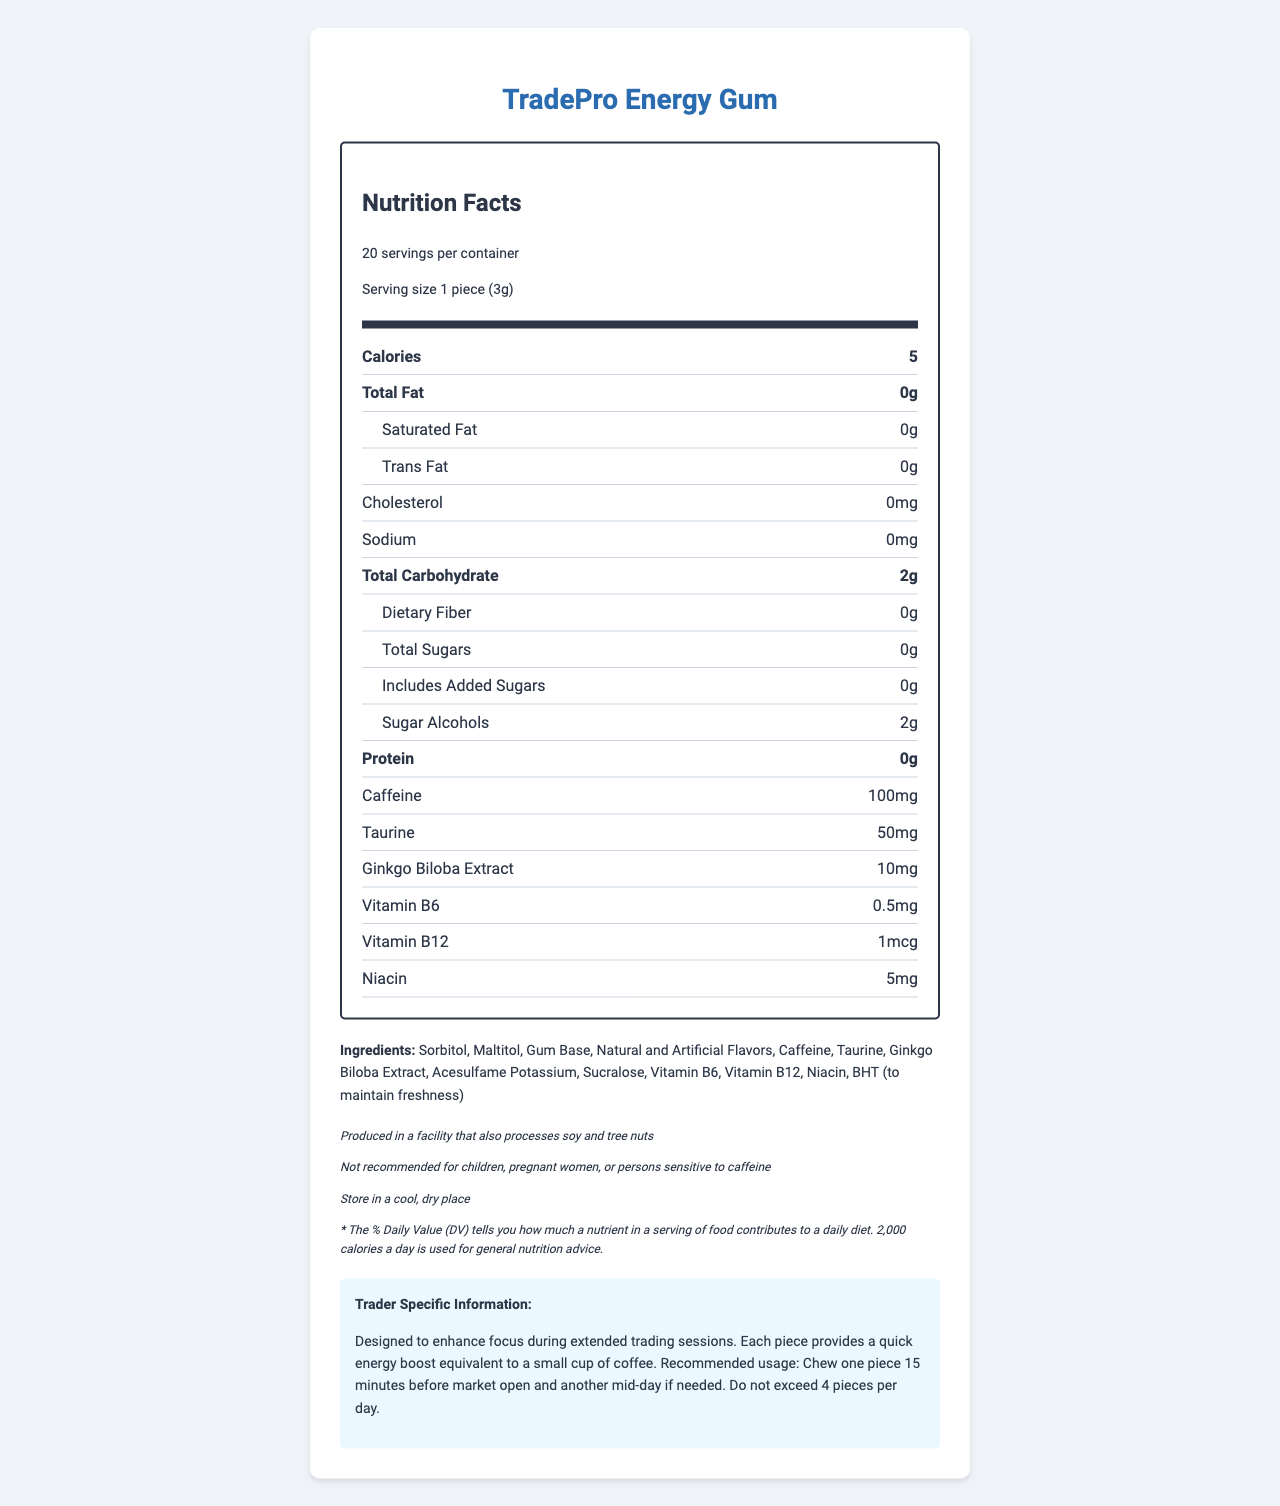what is the serving size? The serving size is specified directly as "1 piece (3g)" in the document.
Answer: 1 piece (3g) how many servings are in the container? The document states that there are "20 servings per container."
Answer: 20 how many calories are in one serving? The document lists the calorie content as "5" for one serving.
Answer: 5 what is the amount of caffeine per piece of gum? The document specifies that each piece contains "100mg" of caffeine.
Answer: 100mg which vitamins are included and in what amounts? The document lists the amounts for Vitamin B6, Vitamin B12, and Niacin in the nutrition facts section.
Answer: Vitamin B6: 0.5mg, Vitamin B12: 1mcg, Niacin: 5mg which ingredient is specifically included to maintain freshness? The ingredient list mentions "BHT (to maintain freshness)."
Answer: BHT is the product recommended for children? The disclaimer section states, "Not recommended for children, pregnant women, or persons sensitive to caffeine."
Answer: No what are the carbohydrate sources in the gum? The document shows that the gum contains 2g of Total Carbohydrates, which are Sugar Alcohols.
Answer: Sugar Alcohols select the correct manufacturer name: A. TradePro Energy, B. TradePro Supplements, C. TradePro Gums The manufacturer is listed as "TradePro Supplements, Inc."
Answer: B how should the product be stored? A. In the fridge, B. In a cool, dry place, C. In a warm, humid place, D. In direct sunlight The document advises storing the product in "a cool, dry place."
Answer: B can someone allergic to tree nuts safely consume this product? The allergen information states, "Produced in a facility that also processes soy and tree nuts."
Answer: No what does the asterisk (*) in the FDA statement refer to? The asterisk refers to a note explaining what "% Daily Value (DV)" means.
Answer: The % Daily Value (DV) tells you how much a nutrient in a serving of food contributes to a daily diet. 2,000 calories a day is used for general nutrition advice. when is the recommended time to chew a piece before market open? The trader-specific information advises chewing one piece "15 minutes before market open."
Answer: 15 minutes before market open how many pieces of gum can be consumed per day? The trader-specific information clearly states, "Do not exceed 4 pieces per day."
Answer: Do not exceed 4 pieces per day which of the following is a key ingredient that boosts alertness? A. Sucralose, B. Caffeine, C. Taurine, D. Ginkgo Biloba Extract Caffeine is emphasized as a key ingredient to boost alertness, providing "a quick energy boost equivalent to a small cup of coffee."
Answer: B summarize the key information provided about the product. The summary provides an overall description of the product's intended use, key nutritional information, and usage guidelines. It also includes storage recommendations and safety disclaimers.
Answer: TradePro Energy Gum is a caffeinated gum designed to enhance focus during long trading sessions. Each piece contains 5 calories, 100mg of caffeine, and several B-vitamins, among other ingredients. It is recommended to chew one piece 15 minutes before market open and another mid-day if needed, with a maximum of 4 pieces per day. The product should be stored in a cool, dry place and is not recommended for children or pregnant women. what is the percentage daily value for vitamin d? The document does not include any information about the percentage daily value for Vitamin D.
Answer: Cannot be determined 